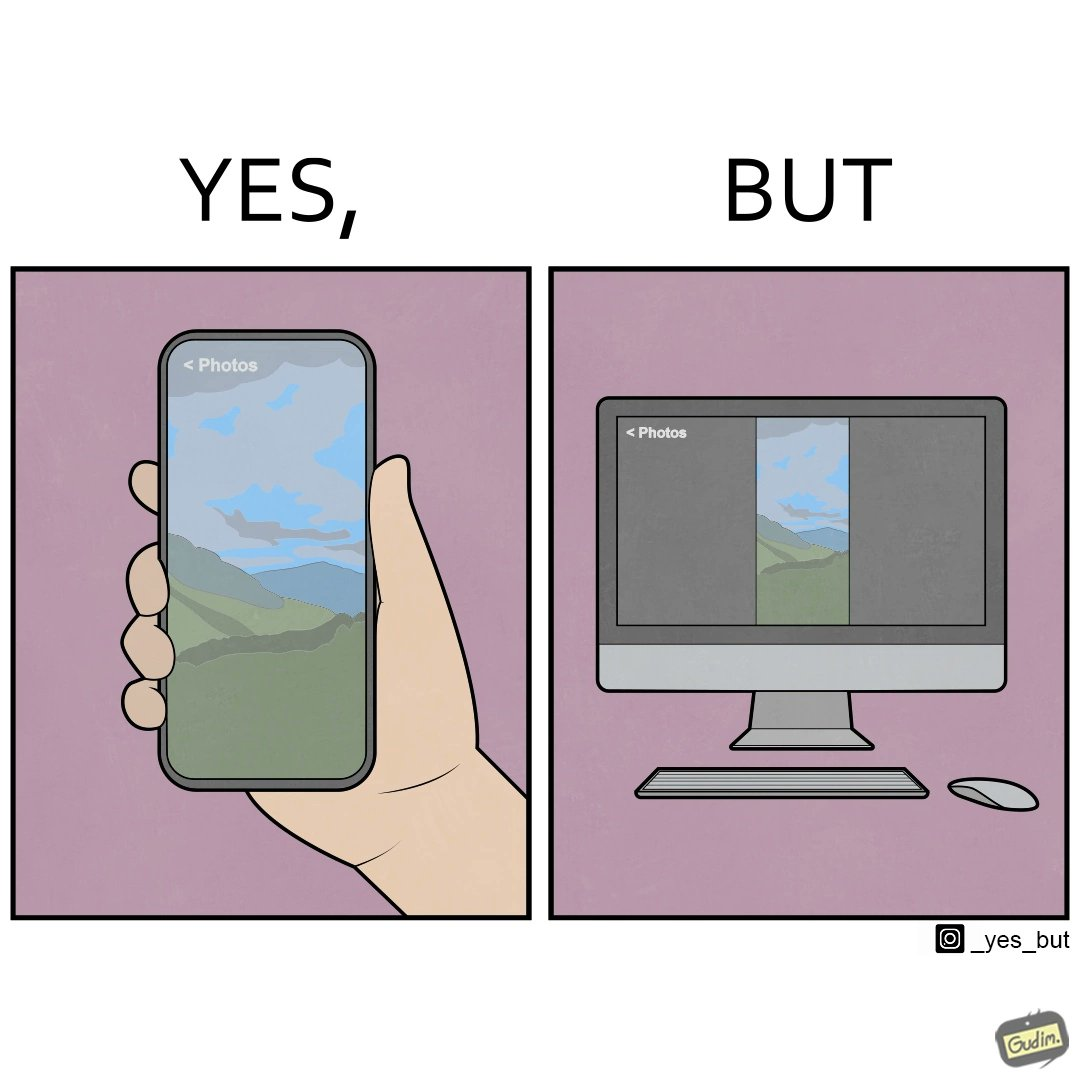Describe the satirical element in this image. This image is funny, as when using the "photos" app on mobile, it shows you images perfectly, which fill the entire screen, but when viewing the same photos on the computer monitor, the same images have a very limited coverage of the screen. 